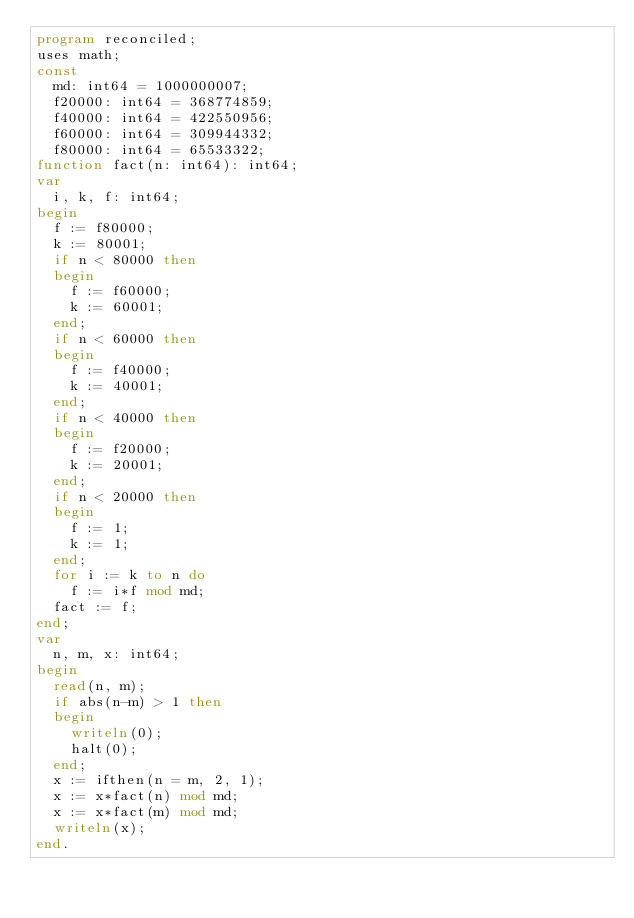<code> <loc_0><loc_0><loc_500><loc_500><_Pascal_>program reconciled;
uses math;
const
  md: int64 = 1000000007;
  f20000: int64 = 368774859;
  f40000: int64 = 422550956;
  f60000: int64 = 309944332;
  f80000: int64 = 65533322;
function fact(n: int64): int64;
var
  i, k, f: int64;
begin
  f := f80000;
  k := 80001;
  if n < 80000 then
  begin
    f := f60000;
    k := 60001;
  end;
  if n < 60000 then
  begin
    f := f40000;
    k := 40001;
  end;
  if n < 40000 then
  begin
    f := f20000;
    k := 20001;
  end;
  if n < 20000 then
  begin
    f := 1;
    k := 1;
  end;
  for i := k to n do
    f := i*f mod md;
  fact := f;
end;
var
  n, m, x: int64;
begin
  read(n, m);
  if abs(n-m) > 1 then
  begin
    writeln(0);
    halt(0);
  end;
  x := ifthen(n = m, 2, 1);
  x := x*fact(n) mod md;
  x := x*fact(m) mod md;
  writeln(x);
end.</code> 